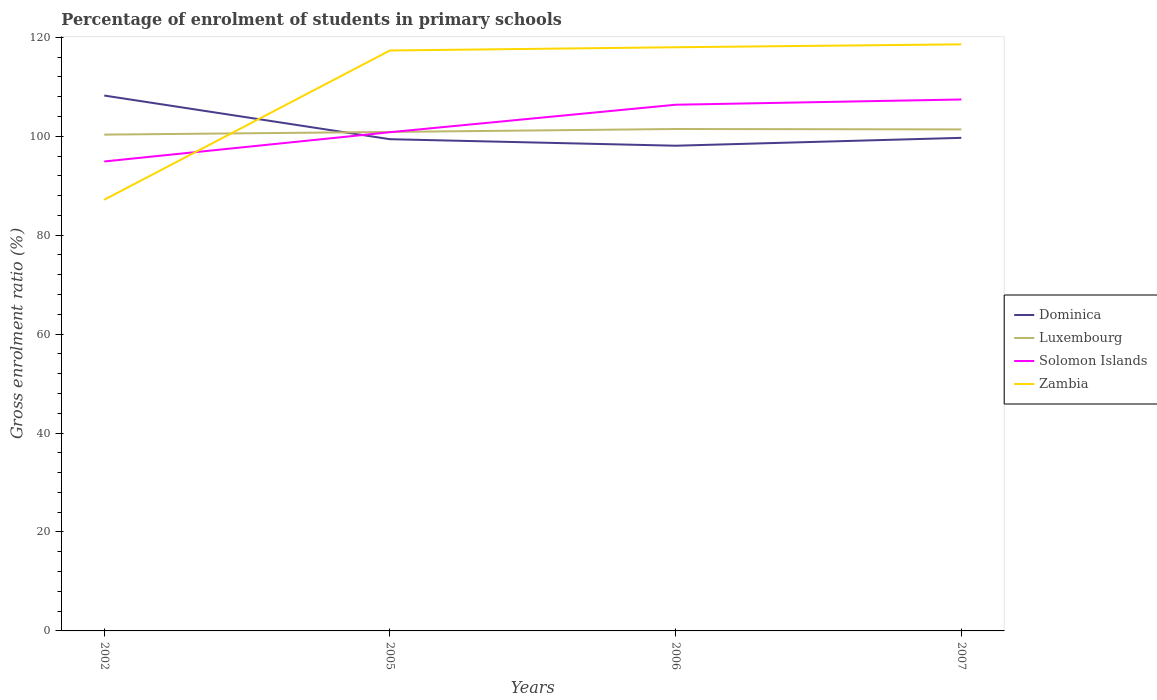How many different coloured lines are there?
Offer a very short reply. 4. Does the line corresponding to Solomon Islands intersect with the line corresponding to Luxembourg?
Give a very brief answer. Yes. Is the number of lines equal to the number of legend labels?
Offer a terse response. Yes. Across all years, what is the maximum percentage of students enrolled in primary schools in Dominica?
Offer a terse response. 98.08. In which year was the percentage of students enrolled in primary schools in Dominica maximum?
Keep it short and to the point. 2006. What is the total percentage of students enrolled in primary schools in Solomon Islands in the graph?
Provide a short and direct response. -5.56. What is the difference between the highest and the second highest percentage of students enrolled in primary schools in Dominica?
Keep it short and to the point. 10.14. What is the difference between the highest and the lowest percentage of students enrolled in primary schools in Zambia?
Provide a succinct answer. 3. Is the percentage of students enrolled in primary schools in Dominica strictly greater than the percentage of students enrolled in primary schools in Solomon Islands over the years?
Provide a short and direct response. No. How many lines are there?
Your answer should be compact. 4. What is the difference between two consecutive major ticks on the Y-axis?
Your response must be concise. 20. What is the title of the graph?
Give a very brief answer. Percentage of enrolment of students in primary schools. What is the label or title of the X-axis?
Offer a very short reply. Years. What is the Gross enrolment ratio (%) of Dominica in 2002?
Provide a succinct answer. 108.23. What is the Gross enrolment ratio (%) of Luxembourg in 2002?
Keep it short and to the point. 100.33. What is the Gross enrolment ratio (%) in Solomon Islands in 2002?
Provide a short and direct response. 94.9. What is the Gross enrolment ratio (%) of Zambia in 2002?
Keep it short and to the point. 87.17. What is the Gross enrolment ratio (%) of Dominica in 2005?
Make the answer very short. 99.4. What is the Gross enrolment ratio (%) of Luxembourg in 2005?
Provide a short and direct response. 100.87. What is the Gross enrolment ratio (%) of Solomon Islands in 2005?
Ensure brevity in your answer.  100.81. What is the Gross enrolment ratio (%) of Zambia in 2005?
Ensure brevity in your answer.  117.33. What is the Gross enrolment ratio (%) of Dominica in 2006?
Your response must be concise. 98.08. What is the Gross enrolment ratio (%) in Luxembourg in 2006?
Make the answer very short. 101.46. What is the Gross enrolment ratio (%) in Solomon Islands in 2006?
Ensure brevity in your answer.  106.37. What is the Gross enrolment ratio (%) of Zambia in 2006?
Ensure brevity in your answer.  117.99. What is the Gross enrolment ratio (%) in Dominica in 2007?
Your answer should be compact. 99.68. What is the Gross enrolment ratio (%) of Luxembourg in 2007?
Provide a succinct answer. 101.38. What is the Gross enrolment ratio (%) of Solomon Islands in 2007?
Your answer should be very brief. 107.43. What is the Gross enrolment ratio (%) of Zambia in 2007?
Your answer should be compact. 118.58. Across all years, what is the maximum Gross enrolment ratio (%) of Dominica?
Offer a terse response. 108.23. Across all years, what is the maximum Gross enrolment ratio (%) in Luxembourg?
Provide a short and direct response. 101.46. Across all years, what is the maximum Gross enrolment ratio (%) of Solomon Islands?
Give a very brief answer. 107.43. Across all years, what is the maximum Gross enrolment ratio (%) in Zambia?
Offer a very short reply. 118.58. Across all years, what is the minimum Gross enrolment ratio (%) of Dominica?
Your response must be concise. 98.08. Across all years, what is the minimum Gross enrolment ratio (%) in Luxembourg?
Your response must be concise. 100.33. Across all years, what is the minimum Gross enrolment ratio (%) in Solomon Islands?
Make the answer very short. 94.9. Across all years, what is the minimum Gross enrolment ratio (%) in Zambia?
Provide a short and direct response. 87.17. What is the total Gross enrolment ratio (%) of Dominica in the graph?
Keep it short and to the point. 405.39. What is the total Gross enrolment ratio (%) in Luxembourg in the graph?
Give a very brief answer. 404.04. What is the total Gross enrolment ratio (%) in Solomon Islands in the graph?
Give a very brief answer. 409.51. What is the total Gross enrolment ratio (%) of Zambia in the graph?
Provide a short and direct response. 441.07. What is the difference between the Gross enrolment ratio (%) of Dominica in 2002 and that in 2005?
Your response must be concise. 8.83. What is the difference between the Gross enrolment ratio (%) in Luxembourg in 2002 and that in 2005?
Offer a terse response. -0.54. What is the difference between the Gross enrolment ratio (%) of Solomon Islands in 2002 and that in 2005?
Your response must be concise. -5.91. What is the difference between the Gross enrolment ratio (%) of Zambia in 2002 and that in 2005?
Ensure brevity in your answer.  -30.17. What is the difference between the Gross enrolment ratio (%) of Dominica in 2002 and that in 2006?
Make the answer very short. 10.14. What is the difference between the Gross enrolment ratio (%) in Luxembourg in 2002 and that in 2006?
Your answer should be very brief. -1.14. What is the difference between the Gross enrolment ratio (%) in Solomon Islands in 2002 and that in 2006?
Provide a succinct answer. -11.47. What is the difference between the Gross enrolment ratio (%) in Zambia in 2002 and that in 2006?
Give a very brief answer. -30.82. What is the difference between the Gross enrolment ratio (%) of Dominica in 2002 and that in 2007?
Your answer should be very brief. 8.55. What is the difference between the Gross enrolment ratio (%) in Luxembourg in 2002 and that in 2007?
Make the answer very short. -1.05. What is the difference between the Gross enrolment ratio (%) in Solomon Islands in 2002 and that in 2007?
Offer a very short reply. -12.53. What is the difference between the Gross enrolment ratio (%) in Zambia in 2002 and that in 2007?
Ensure brevity in your answer.  -31.41. What is the difference between the Gross enrolment ratio (%) of Dominica in 2005 and that in 2006?
Make the answer very short. 1.31. What is the difference between the Gross enrolment ratio (%) in Luxembourg in 2005 and that in 2006?
Your answer should be very brief. -0.59. What is the difference between the Gross enrolment ratio (%) of Solomon Islands in 2005 and that in 2006?
Offer a terse response. -5.56. What is the difference between the Gross enrolment ratio (%) in Zambia in 2005 and that in 2006?
Give a very brief answer. -0.66. What is the difference between the Gross enrolment ratio (%) in Dominica in 2005 and that in 2007?
Give a very brief answer. -0.28. What is the difference between the Gross enrolment ratio (%) of Luxembourg in 2005 and that in 2007?
Provide a short and direct response. -0.51. What is the difference between the Gross enrolment ratio (%) in Solomon Islands in 2005 and that in 2007?
Offer a very short reply. -6.62. What is the difference between the Gross enrolment ratio (%) of Zambia in 2005 and that in 2007?
Your answer should be compact. -1.24. What is the difference between the Gross enrolment ratio (%) of Dominica in 2006 and that in 2007?
Provide a short and direct response. -1.59. What is the difference between the Gross enrolment ratio (%) of Luxembourg in 2006 and that in 2007?
Ensure brevity in your answer.  0.08. What is the difference between the Gross enrolment ratio (%) in Solomon Islands in 2006 and that in 2007?
Your answer should be compact. -1.06. What is the difference between the Gross enrolment ratio (%) of Zambia in 2006 and that in 2007?
Provide a short and direct response. -0.59. What is the difference between the Gross enrolment ratio (%) in Dominica in 2002 and the Gross enrolment ratio (%) in Luxembourg in 2005?
Your answer should be compact. 7.36. What is the difference between the Gross enrolment ratio (%) in Dominica in 2002 and the Gross enrolment ratio (%) in Solomon Islands in 2005?
Provide a succinct answer. 7.41. What is the difference between the Gross enrolment ratio (%) of Dominica in 2002 and the Gross enrolment ratio (%) of Zambia in 2005?
Offer a terse response. -9.11. What is the difference between the Gross enrolment ratio (%) of Luxembourg in 2002 and the Gross enrolment ratio (%) of Solomon Islands in 2005?
Your answer should be compact. -0.49. What is the difference between the Gross enrolment ratio (%) of Luxembourg in 2002 and the Gross enrolment ratio (%) of Zambia in 2005?
Keep it short and to the point. -17.01. What is the difference between the Gross enrolment ratio (%) in Solomon Islands in 2002 and the Gross enrolment ratio (%) in Zambia in 2005?
Provide a short and direct response. -22.43. What is the difference between the Gross enrolment ratio (%) in Dominica in 2002 and the Gross enrolment ratio (%) in Luxembourg in 2006?
Your response must be concise. 6.76. What is the difference between the Gross enrolment ratio (%) in Dominica in 2002 and the Gross enrolment ratio (%) in Solomon Islands in 2006?
Provide a succinct answer. 1.86. What is the difference between the Gross enrolment ratio (%) in Dominica in 2002 and the Gross enrolment ratio (%) in Zambia in 2006?
Ensure brevity in your answer.  -9.76. What is the difference between the Gross enrolment ratio (%) of Luxembourg in 2002 and the Gross enrolment ratio (%) of Solomon Islands in 2006?
Your answer should be compact. -6.04. What is the difference between the Gross enrolment ratio (%) in Luxembourg in 2002 and the Gross enrolment ratio (%) in Zambia in 2006?
Ensure brevity in your answer.  -17.66. What is the difference between the Gross enrolment ratio (%) in Solomon Islands in 2002 and the Gross enrolment ratio (%) in Zambia in 2006?
Keep it short and to the point. -23.09. What is the difference between the Gross enrolment ratio (%) of Dominica in 2002 and the Gross enrolment ratio (%) of Luxembourg in 2007?
Your answer should be very brief. 6.85. What is the difference between the Gross enrolment ratio (%) in Dominica in 2002 and the Gross enrolment ratio (%) in Solomon Islands in 2007?
Ensure brevity in your answer.  0.8. What is the difference between the Gross enrolment ratio (%) of Dominica in 2002 and the Gross enrolment ratio (%) of Zambia in 2007?
Give a very brief answer. -10.35. What is the difference between the Gross enrolment ratio (%) in Luxembourg in 2002 and the Gross enrolment ratio (%) in Solomon Islands in 2007?
Make the answer very short. -7.1. What is the difference between the Gross enrolment ratio (%) of Luxembourg in 2002 and the Gross enrolment ratio (%) of Zambia in 2007?
Your response must be concise. -18.25. What is the difference between the Gross enrolment ratio (%) in Solomon Islands in 2002 and the Gross enrolment ratio (%) in Zambia in 2007?
Your response must be concise. -23.68. What is the difference between the Gross enrolment ratio (%) in Dominica in 2005 and the Gross enrolment ratio (%) in Luxembourg in 2006?
Your answer should be very brief. -2.06. What is the difference between the Gross enrolment ratio (%) in Dominica in 2005 and the Gross enrolment ratio (%) in Solomon Islands in 2006?
Your answer should be compact. -6.97. What is the difference between the Gross enrolment ratio (%) in Dominica in 2005 and the Gross enrolment ratio (%) in Zambia in 2006?
Provide a short and direct response. -18.59. What is the difference between the Gross enrolment ratio (%) of Luxembourg in 2005 and the Gross enrolment ratio (%) of Solomon Islands in 2006?
Offer a very short reply. -5.5. What is the difference between the Gross enrolment ratio (%) in Luxembourg in 2005 and the Gross enrolment ratio (%) in Zambia in 2006?
Your response must be concise. -17.12. What is the difference between the Gross enrolment ratio (%) of Solomon Islands in 2005 and the Gross enrolment ratio (%) of Zambia in 2006?
Keep it short and to the point. -17.18. What is the difference between the Gross enrolment ratio (%) in Dominica in 2005 and the Gross enrolment ratio (%) in Luxembourg in 2007?
Provide a short and direct response. -1.98. What is the difference between the Gross enrolment ratio (%) in Dominica in 2005 and the Gross enrolment ratio (%) in Solomon Islands in 2007?
Provide a succinct answer. -8.03. What is the difference between the Gross enrolment ratio (%) of Dominica in 2005 and the Gross enrolment ratio (%) of Zambia in 2007?
Make the answer very short. -19.18. What is the difference between the Gross enrolment ratio (%) of Luxembourg in 2005 and the Gross enrolment ratio (%) of Solomon Islands in 2007?
Provide a succinct answer. -6.56. What is the difference between the Gross enrolment ratio (%) in Luxembourg in 2005 and the Gross enrolment ratio (%) in Zambia in 2007?
Keep it short and to the point. -17.71. What is the difference between the Gross enrolment ratio (%) of Solomon Islands in 2005 and the Gross enrolment ratio (%) of Zambia in 2007?
Ensure brevity in your answer.  -17.76. What is the difference between the Gross enrolment ratio (%) in Dominica in 2006 and the Gross enrolment ratio (%) in Luxembourg in 2007?
Provide a short and direct response. -3.3. What is the difference between the Gross enrolment ratio (%) of Dominica in 2006 and the Gross enrolment ratio (%) of Solomon Islands in 2007?
Give a very brief answer. -9.35. What is the difference between the Gross enrolment ratio (%) in Dominica in 2006 and the Gross enrolment ratio (%) in Zambia in 2007?
Your answer should be very brief. -20.49. What is the difference between the Gross enrolment ratio (%) of Luxembourg in 2006 and the Gross enrolment ratio (%) of Solomon Islands in 2007?
Your answer should be very brief. -5.97. What is the difference between the Gross enrolment ratio (%) of Luxembourg in 2006 and the Gross enrolment ratio (%) of Zambia in 2007?
Offer a terse response. -17.11. What is the difference between the Gross enrolment ratio (%) in Solomon Islands in 2006 and the Gross enrolment ratio (%) in Zambia in 2007?
Offer a very short reply. -12.21. What is the average Gross enrolment ratio (%) in Dominica per year?
Your answer should be very brief. 101.35. What is the average Gross enrolment ratio (%) in Luxembourg per year?
Keep it short and to the point. 101.01. What is the average Gross enrolment ratio (%) of Solomon Islands per year?
Your answer should be compact. 102.38. What is the average Gross enrolment ratio (%) in Zambia per year?
Your answer should be compact. 110.27. In the year 2002, what is the difference between the Gross enrolment ratio (%) of Dominica and Gross enrolment ratio (%) of Luxembourg?
Provide a short and direct response. 7.9. In the year 2002, what is the difference between the Gross enrolment ratio (%) in Dominica and Gross enrolment ratio (%) in Solomon Islands?
Offer a terse response. 13.33. In the year 2002, what is the difference between the Gross enrolment ratio (%) in Dominica and Gross enrolment ratio (%) in Zambia?
Your answer should be very brief. 21.06. In the year 2002, what is the difference between the Gross enrolment ratio (%) of Luxembourg and Gross enrolment ratio (%) of Solomon Islands?
Make the answer very short. 5.43. In the year 2002, what is the difference between the Gross enrolment ratio (%) in Luxembourg and Gross enrolment ratio (%) in Zambia?
Keep it short and to the point. 13.16. In the year 2002, what is the difference between the Gross enrolment ratio (%) in Solomon Islands and Gross enrolment ratio (%) in Zambia?
Your response must be concise. 7.73. In the year 2005, what is the difference between the Gross enrolment ratio (%) in Dominica and Gross enrolment ratio (%) in Luxembourg?
Offer a terse response. -1.47. In the year 2005, what is the difference between the Gross enrolment ratio (%) in Dominica and Gross enrolment ratio (%) in Solomon Islands?
Offer a terse response. -1.41. In the year 2005, what is the difference between the Gross enrolment ratio (%) in Dominica and Gross enrolment ratio (%) in Zambia?
Provide a succinct answer. -17.93. In the year 2005, what is the difference between the Gross enrolment ratio (%) in Luxembourg and Gross enrolment ratio (%) in Solomon Islands?
Make the answer very short. 0.06. In the year 2005, what is the difference between the Gross enrolment ratio (%) of Luxembourg and Gross enrolment ratio (%) of Zambia?
Provide a succinct answer. -16.46. In the year 2005, what is the difference between the Gross enrolment ratio (%) of Solomon Islands and Gross enrolment ratio (%) of Zambia?
Make the answer very short. -16.52. In the year 2006, what is the difference between the Gross enrolment ratio (%) of Dominica and Gross enrolment ratio (%) of Luxembourg?
Make the answer very short. -3.38. In the year 2006, what is the difference between the Gross enrolment ratio (%) of Dominica and Gross enrolment ratio (%) of Solomon Islands?
Your response must be concise. -8.28. In the year 2006, what is the difference between the Gross enrolment ratio (%) of Dominica and Gross enrolment ratio (%) of Zambia?
Provide a succinct answer. -19.91. In the year 2006, what is the difference between the Gross enrolment ratio (%) of Luxembourg and Gross enrolment ratio (%) of Solomon Islands?
Give a very brief answer. -4.91. In the year 2006, what is the difference between the Gross enrolment ratio (%) of Luxembourg and Gross enrolment ratio (%) of Zambia?
Your response must be concise. -16.53. In the year 2006, what is the difference between the Gross enrolment ratio (%) in Solomon Islands and Gross enrolment ratio (%) in Zambia?
Ensure brevity in your answer.  -11.62. In the year 2007, what is the difference between the Gross enrolment ratio (%) of Dominica and Gross enrolment ratio (%) of Luxembourg?
Give a very brief answer. -1.7. In the year 2007, what is the difference between the Gross enrolment ratio (%) in Dominica and Gross enrolment ratio (%) in Solomon Islands?
Make the answer very short. -7.75. In the year 2007, what is the difference between the Gross enrolment ratio (%) of Dominica and Gross enrolment ratio (%) of Zambia?
Offer a terse response. -18.9. In the year 2007, what is the difference between the Gross enrolment ratio (%) in Luxembourg and Gross enrolment ratio (%) in Solomon Islands?
Offer a terse response. -6.05. In the year 2007, what is the difference between the Gross enrolment ratio (%) in Luxembourg and Gross enrolment ratio (%) in Zambia?
Make the answer very short. -17.2. In the year 2007, what is the difference between the Gross enrolment ratio (%) in Solomon Islands and Gross enrolment ratio (%) in Zambia?
Give a very brief answer. -11.15. What is the ratio of the Gross enrolment ratio (%) of Dominica in 2002 to that in 2005?
Give a very brief answer. 1.09. What is the ratio of the Gross enrolment ratio (%) of Luxembourg in 2002 to that in 2005?
Keep it short and to the point. 0.99. What is the ratio of the Gross enrolment ratio (%) of Solomon Islands in 2002 to that in 2005?
Provide a short and direct response. 0.94. What is the ratio of the Gross enrolment ratio (%) in Zambia in 2002 to that in 2005?
Give a very brief answer. 0.74. What is the ratio of the Gross enrolment ratio (%) in Dominica in 2002 to that in 2006?
Keep it short and to the point. 1.1. What is the ratio of the Gross enrolment ratio (%) of Luxembourg in 2002 to that in 2006?
Your answer should be very brief. 0.99. What is the ratio of the Gross enrolment ratio (%) of Solomon Islands in 2002 to that in 2006?
Your answer should be compact. 0.89. What is the ratio of the Gross enrolment ratio (%) in Zambia in 2002 to that in 2006?
Offer a terse response. 0.74. What is the ratio of the Gross enrolment ratio (%) of Dominica in 2002 to that in 2007?
Your answer should be very brief. 1.09. What is the ratio of the Gross enrolment ratio (%) in Luxembourg in 2002 to that in 2007?
Make the answer very short. 0.99. What is the ratio of the Gross enrolment ratio (%) of Solomon Islands in 2002 to that in 2007?
Provide a succinct answer. 0.88. What is the ratio of the Gross enrolment ratio (%) of Zambia in 2002 to that in 2007?
Give a very brief answer. 0.74. What is the ratio of the Gross enrolment ratio (%) of Dominica in 2005 to that in 2006?
Your answer should be compact. 1.01. What is the ratio of the Gross enrolment ratio (%) of Solomon Islands in 2005 to that in 2006?
Ensure brevity in your answer.  0.95. What is the ratio of the Gross enrolment ratio (%) of Zambia in 2005 to that in 2006?
Your answer should be very brief. 0.99. What is the ratio of the Gross enrolment ratio (%) in Solomon Islands in 2005 to that in 2007?
Your answer should be compact. 0.94. What is the ratio of the Gross enrolment ratio (%) in Dominica in 2006 to that in 2007?
Make the answer very short. 0.98. What is the ratio of the Gross enrolment ratio (%) of Luxembourg in 2006 to that in 2007?
Provide a short and direct response. 1. What is the ratio of the Gross enrolment ratio (%) in Zambia in 2006 to that in 2007?
Give a very brief answer. 1. What is the difference between the highest and the second highest Gross enrolment ratio (%) in Dominica?
Offer a terse response. 8.55. What is the difference between the highest and the second highest Gross enrolment ratio (%) of Luxembourg?
Ensure brevity in your answer.  0.08. What is the difference between the highest and the second highest Gross enrolment ratio (%) in Solomon Islands?
Ensure brevity in your answer.  1.06. What is the difference between the highest and the second highest Gross enrolment ratio (%) of Zambia?
Provide a succinct answer. 0.59. What is the difference between the highest and the lowest Gross enrolment ratio (%) in Dominica?
Your answer should be compact. 10.14. What is the difference between the highest and the lowest Gross enrolment ratio (%) in Luxembourg?
Give a very brief answer. 1.14. What is the difference between the highest and the lowest Gross enrolment ratio (%) in Solomon Islands?
Offer a terse response. 12.53. What is the difference between the highest and the lowest Gross enrolment ratio (%) in Zambia?
Your answer should be very brief. 31.41. 